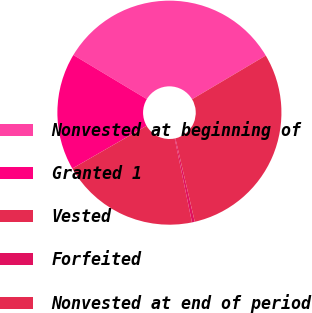Convert chart to OTSL. <chart><loc_0><loc_0><loc_500><loc_500><pie_chart><fcel>Nonvested at beginning of<fcel>Granted 1<fcel>Vested<fcel>Forfeited<fcel>Nonvested at end of period<nl><fcel>32.88%<fcel>16.92%<fcel>19.92%<fcel>0.41%<fcel>29.88%<nl></chart> 